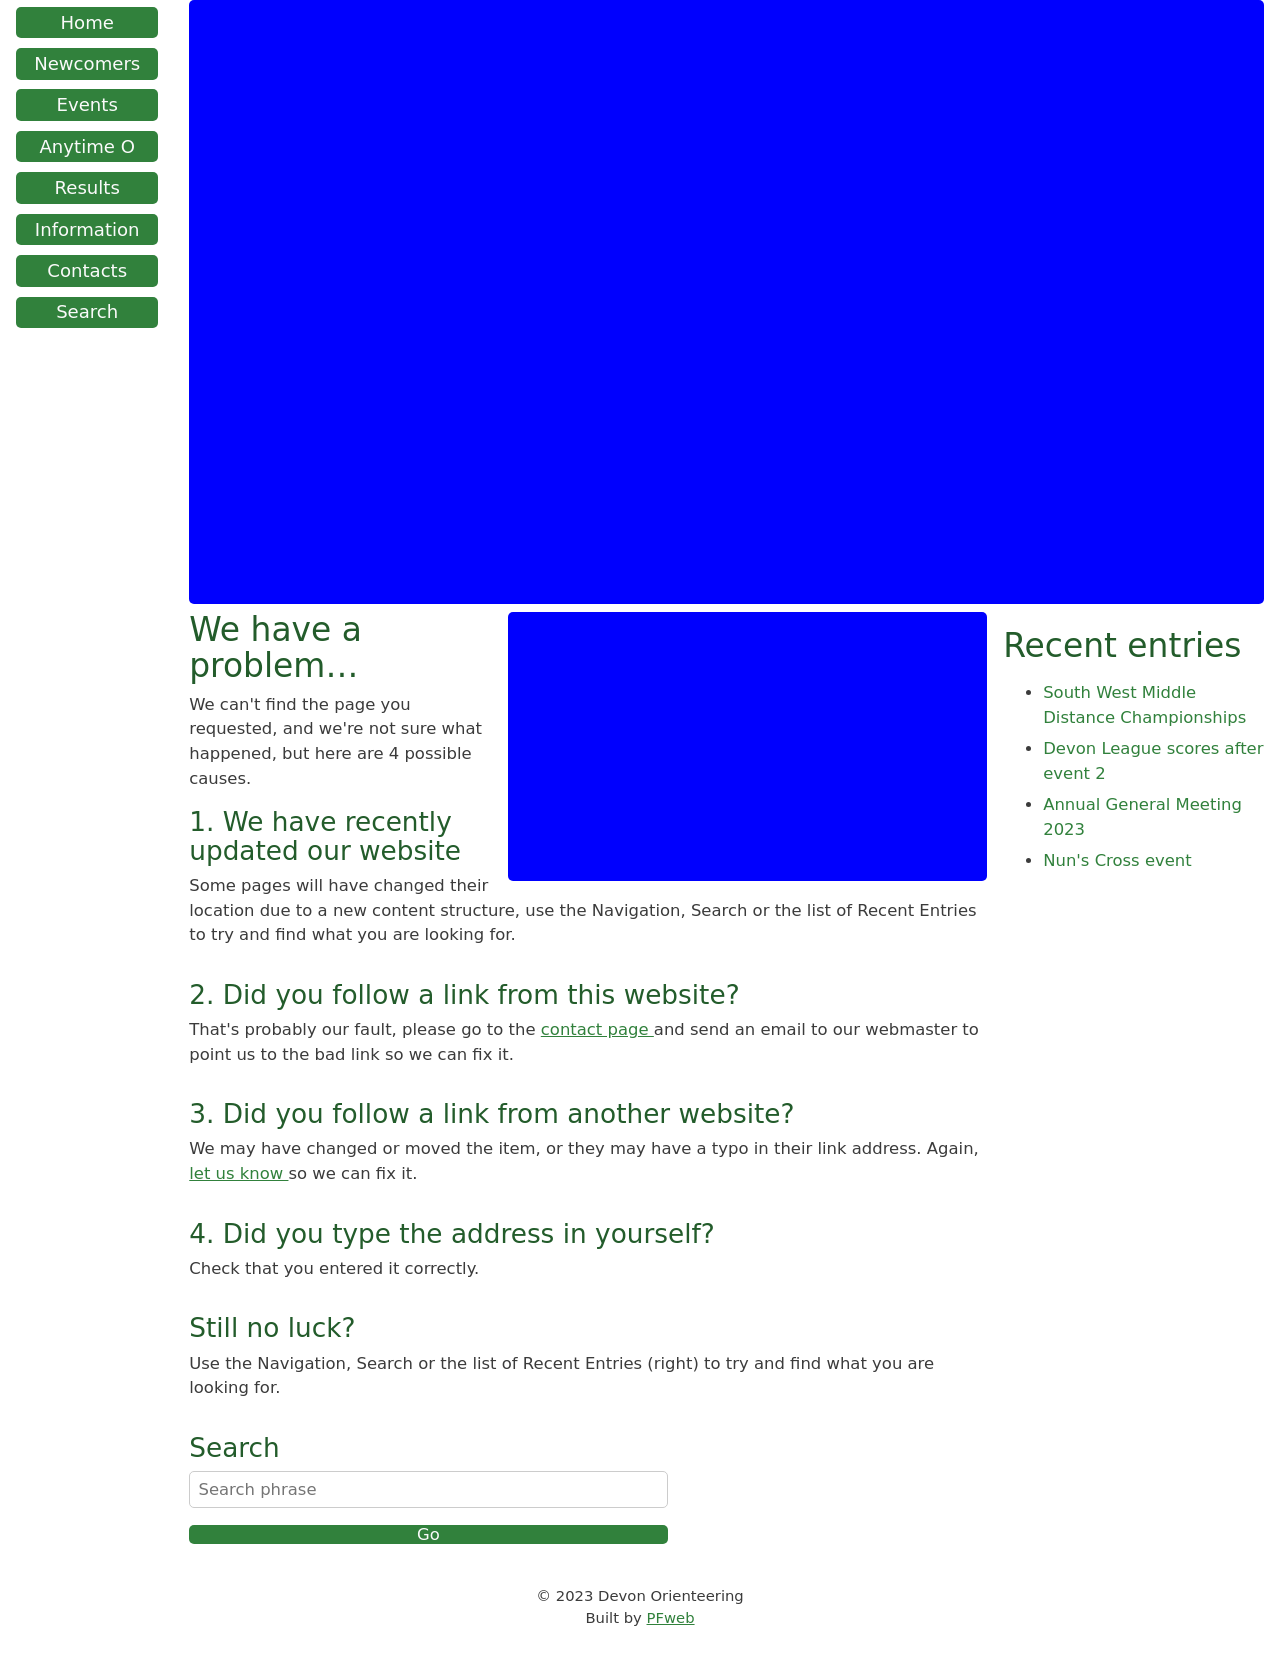How can I start building this website with HTML from the ground up? To start building a website with HTML from the ground up, begin by setting up the basic structure. First, create an HTML file with the basic document structure using the <!DOCTYPE html>, <html>, <head>, and <body> tags. In the <head> section, include meta tags for character set and viewport settings to ensure your site is mobile-responsive. Title your page appropriately using the <title> tag. Within the <body>, you can start laying out your webpage using semantic tags like <header>, <nav>, <main>, <aside>, and <footer> to create a logical structure. Fill these sections with relevant content using tags like <h1> through <h6> for headers, <p> for paragraphs, <a> for links, and <img> for images. Utilize <ul> or <ol> for lists, and <div> for divisions or sections. As you familiarize yourself with these basic tags, you can then explore more complex functionalities using CSS for styling and JavaScript for dynamic elements. 